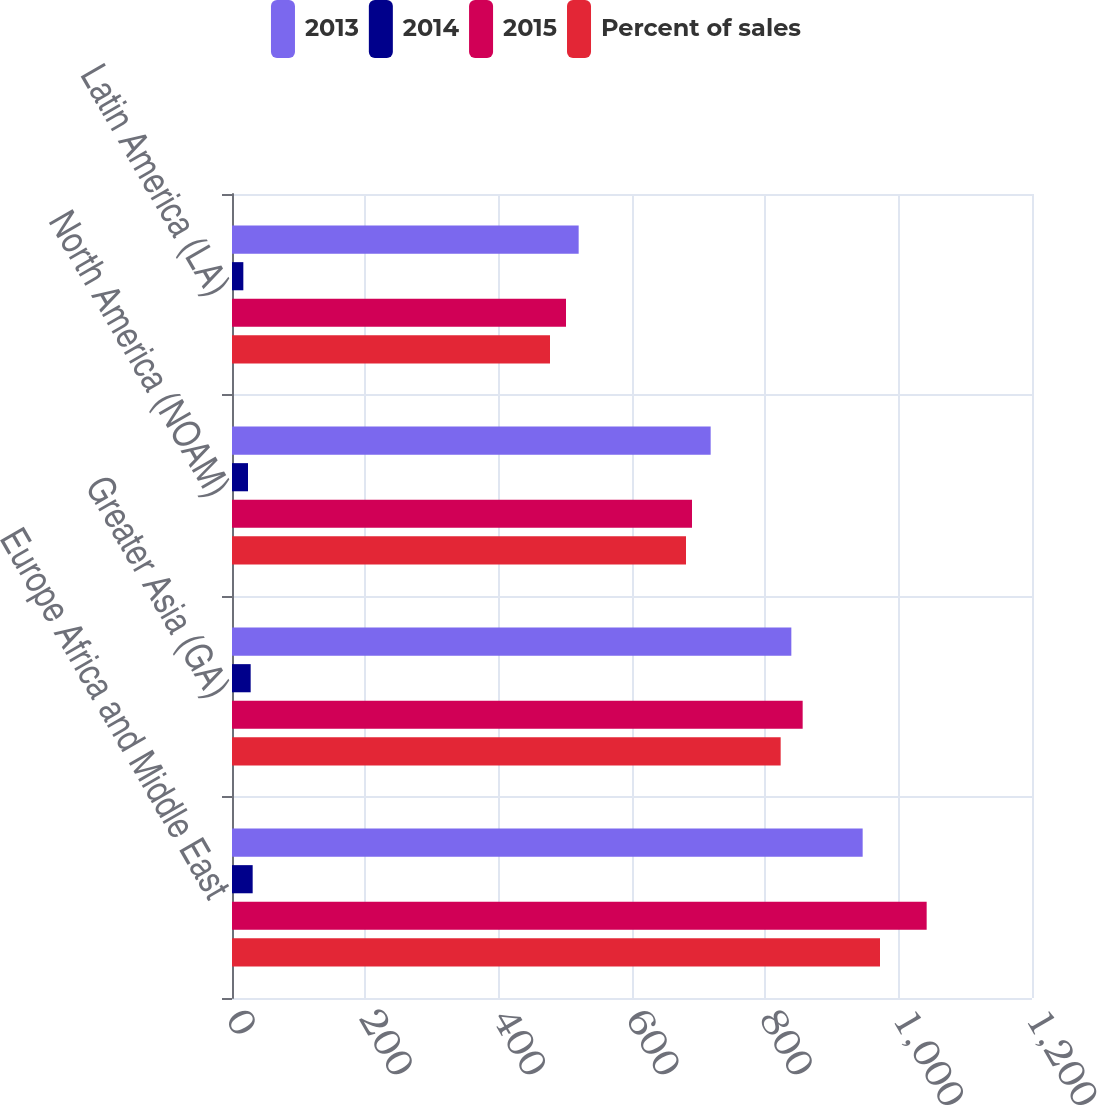Convert chart to OTSL. <chart><loc_0><loc_0><loc_500><loc_500><stacked_bar_chart><ecel><fcel>Europe Africa and Middle East<fcel>Greater Asia (GA)<fcel>North America (NOAM)<fcel>Latin America (LA)<nl><fcel>2013<fcel>946<fcel>839<fcel>718<fcel>520<nl><fcel>2014<fcel>31<fcel>28<fcel>24<fcel>17<nl><fcel>2015<fcel>1042<fcel>856<fcel>690<fcel>501<nl><fcel>Percent of sales<fcel>972<fcel>823<fcel>681<fcel>477<nl></chart> 